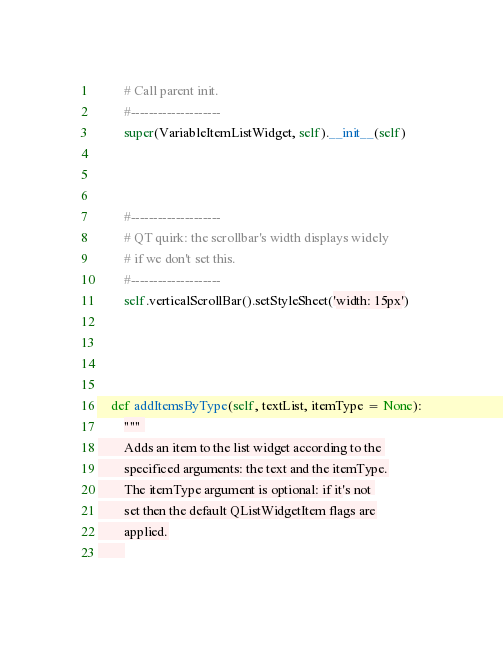<code> <loc_0><loc_0><loc_500><loc_500><_Python_>        # Call parent init.
        #--------------------
        super(VariableItemListWidget, self).__init__(self)


        
        #--------------------
        # QT quirk: the scrollbar's width displays widely 
        # if we don't set this.
        #--------------------
        self.verticalScrollBar().setStyleSheet('width: 15px')


        

    def addItemsByType(self, textList, itemType = None):
        """ 
        Adds an item to the list widget according to the 
        specificed arguments: the text and the itemType.
        The itemType argument is optional: if it's not 
        set then the default QListWidgetItem flags are
        applied.
        </code> 